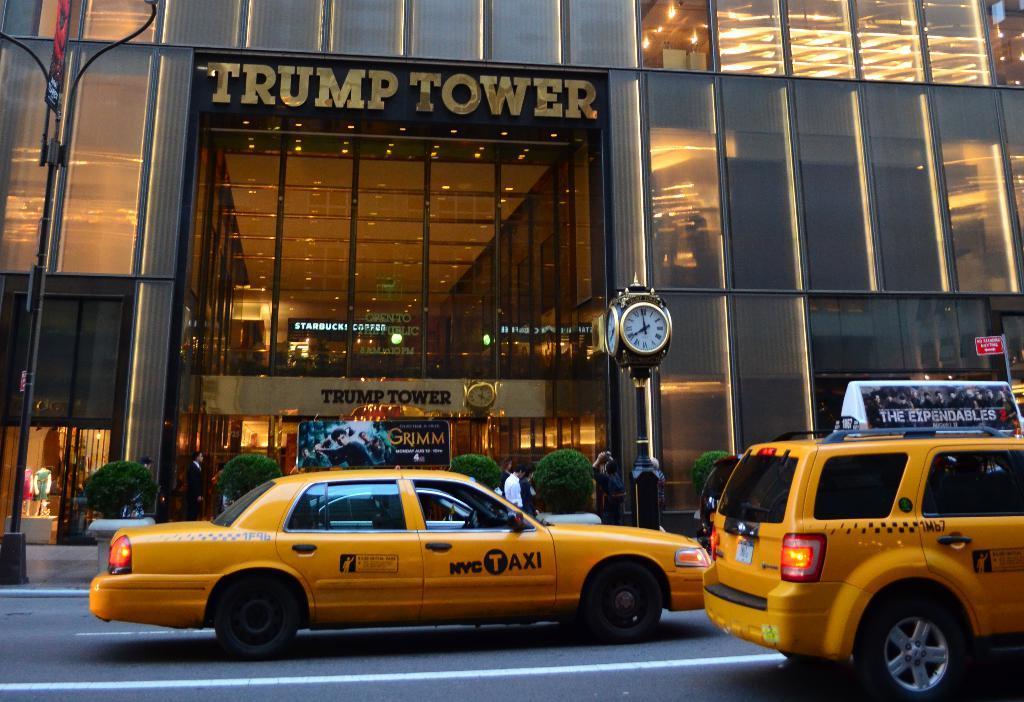Can you describe this image briefly? This is a building with the glass doors and lighting. I think this is a kind of steam clock. These are the cars on the road. I can see the small trees. There are few people standing. This is a name board attached to the building. 